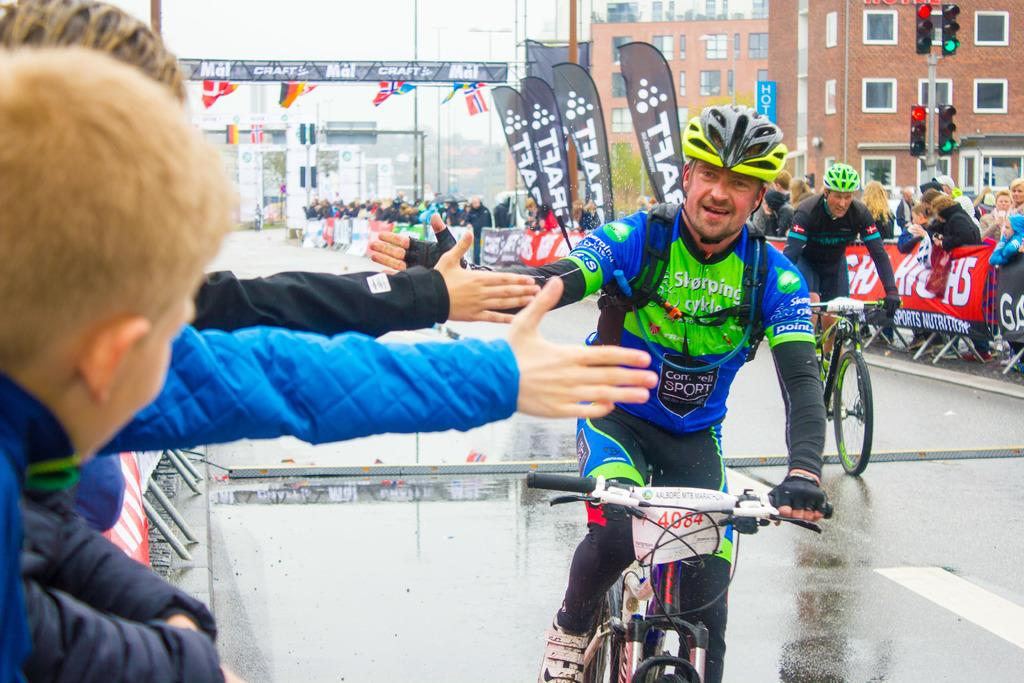What are the people in the image doing? People are riding bicycles on the road. Are there any spectators in the image? Yes, people are watching the cyclists on the left and right. What can be seen on the right side of the image? There are buildings on the right side of the image. What might control the flow of traffic in the image? There is a traffic signal in the image. How many sticks are being used by the cyclists in the image? There are no sticks visible in the image; the cyclists are riding bicycles. What type of account is being discussed by the people watching the cyclists? There is no discussion of any account in the image; people are simply watching the cyclists. 